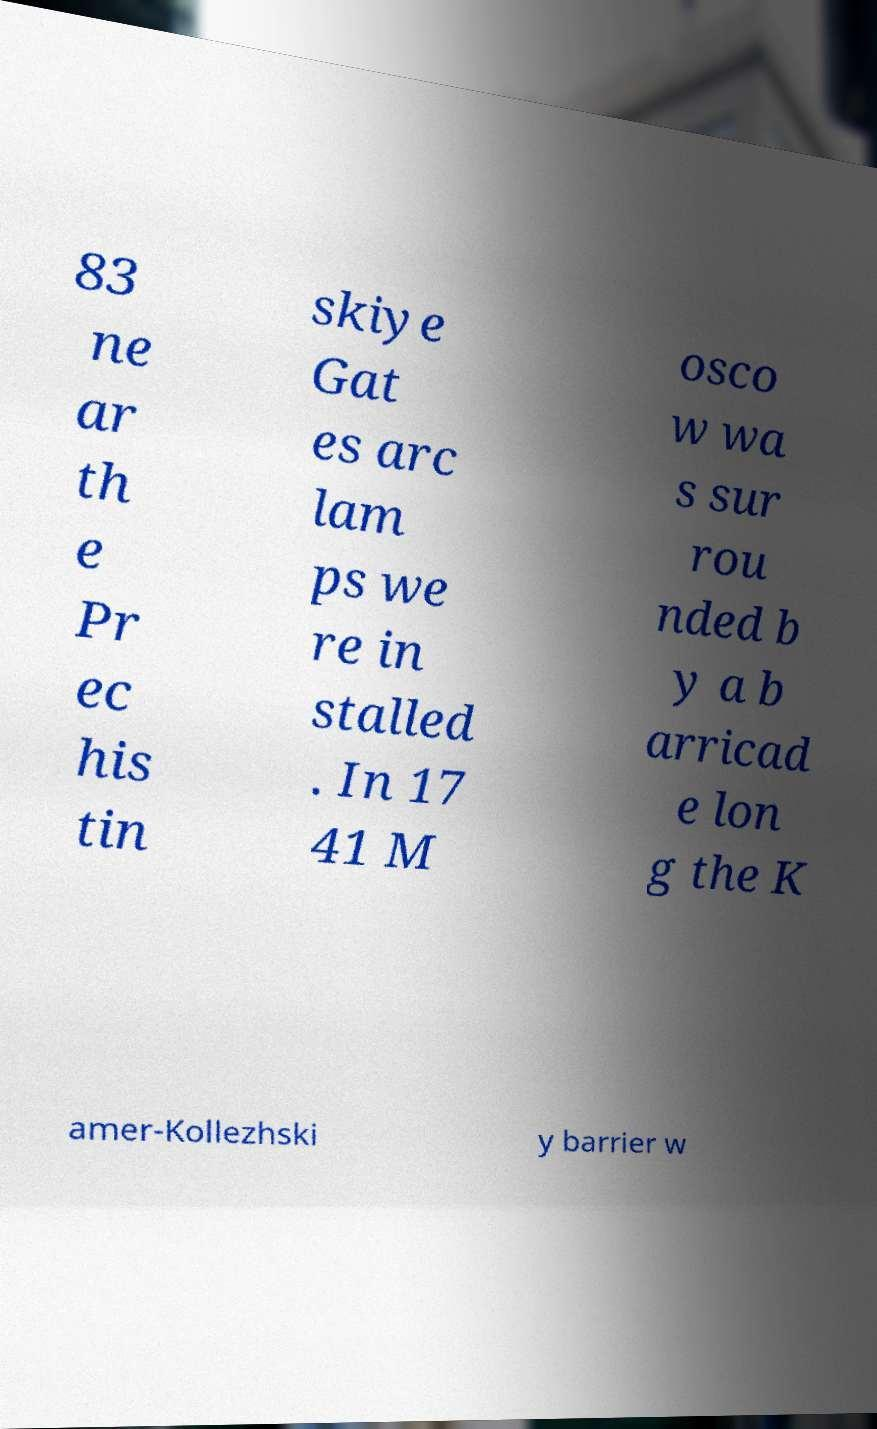Can you accurately transcribe the text from the provided image for me? 83 ne ar th e Pr ec his tin skiye Gat es arc lam ps we re in stalled . In 17 41 M osco w wa s sur rou nded b y a b arricad e lon g the K amer-Kollezhski y barrier w 